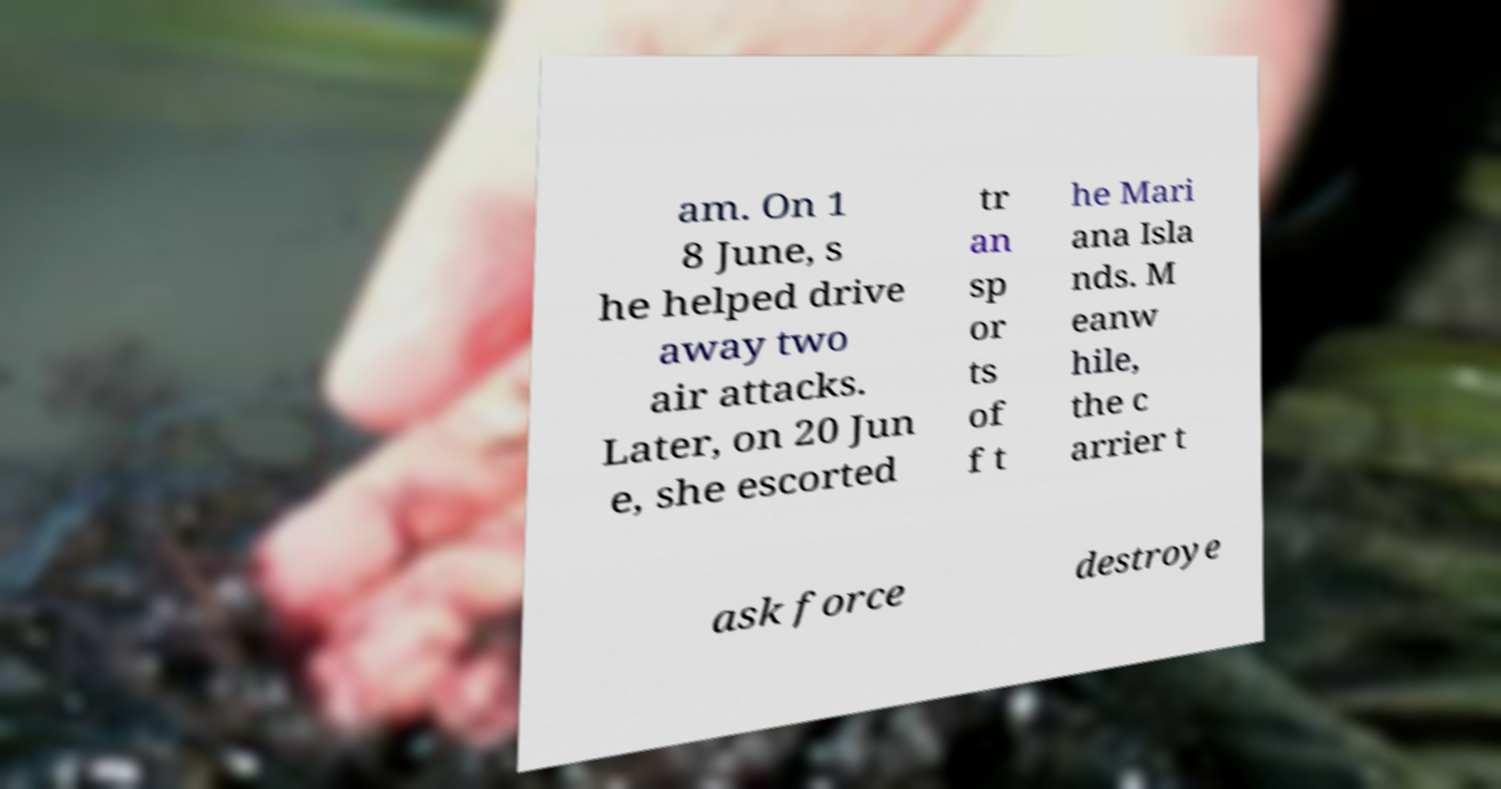Could you assist in decoding the text presented in this image and type it out clearly? am. On 1 8 June, s he helped drive away two air attacks. Later, on 20 Jun e, she escorted tr an sp or ts of f t he Mari ana Isla nds. M eanw hile, the c arrier t ask force destroye 